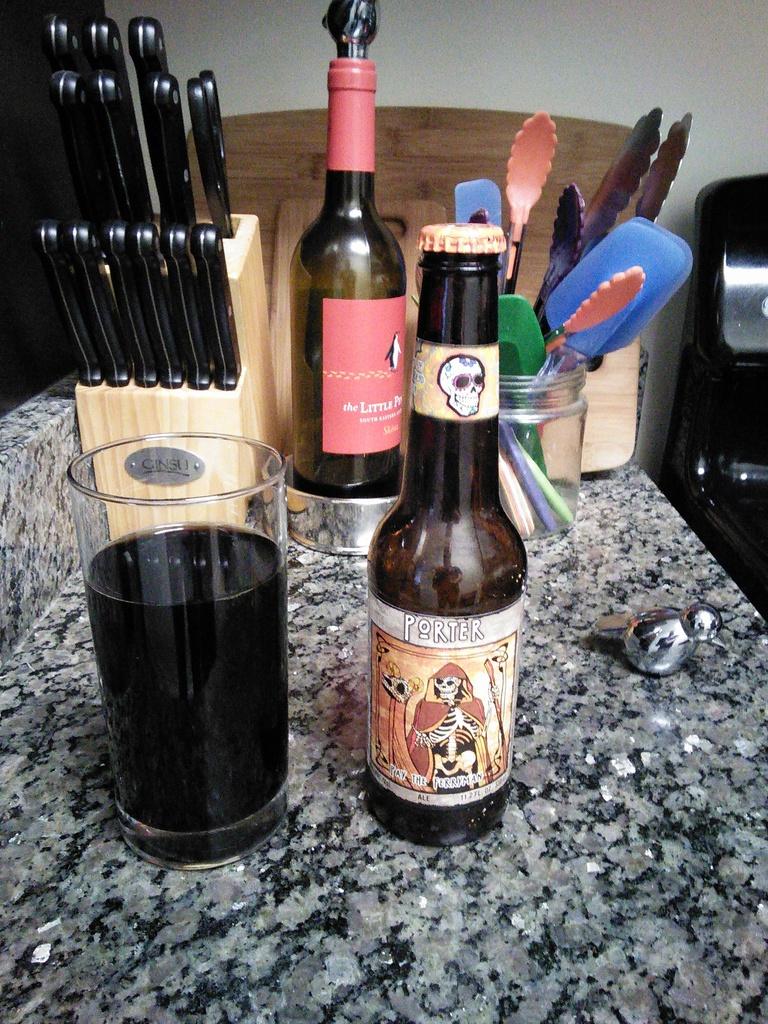What is the brand name of the beer in the front?
Ensure brevity in your answer.  Porter. What are the first 2 words on the wine bottle?
Your answer should be very brief. The little. 